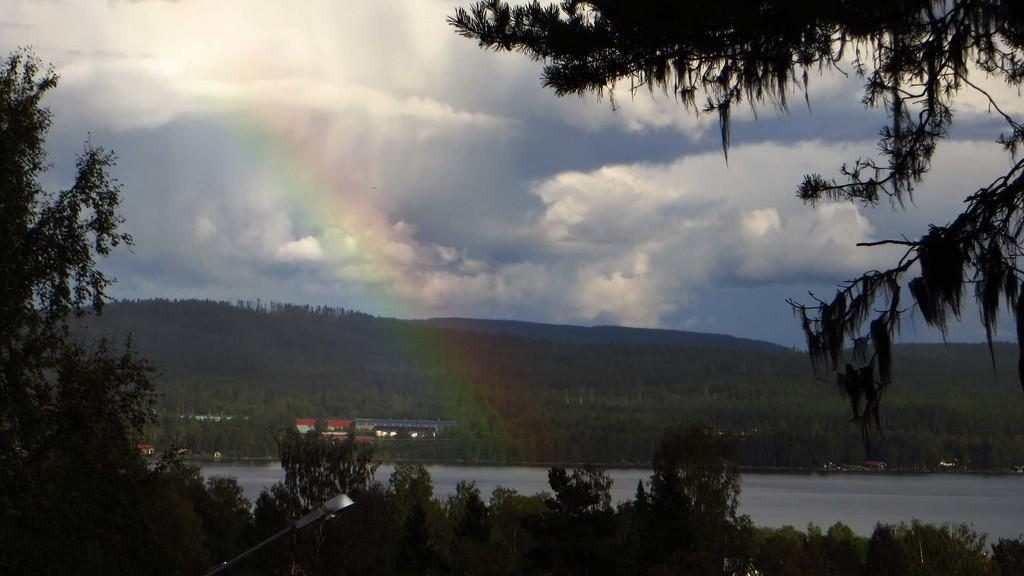What is the main feature of the landscape in the image? There is a lake in the image. What type of vegetation is present in the image? There are many trees in the image. Are there any human-made structures visible in the image? Yes, there are few houses in the image. How would you describe the sky in the image? The sky is blue and cloudy in the image. How many eyes can be seen on the trees in the image? There are no eyes visible on the trees in the image, as trees do not have eyes. 